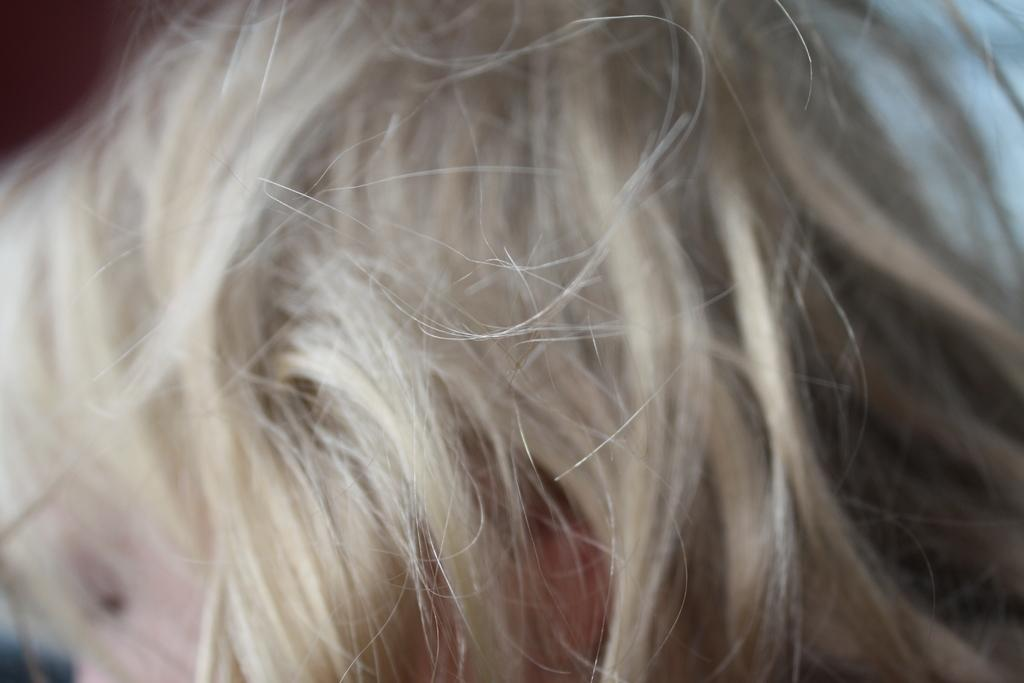What is present in the image? There is a person in the image. Can you describe the person's appearance? The person has hair. How many bikes are being ridden by the person in the image? There are no bikes present in the image. What type of harmony is the person playing in the image? There is no indication of any musical instruments or harmony in the image. 